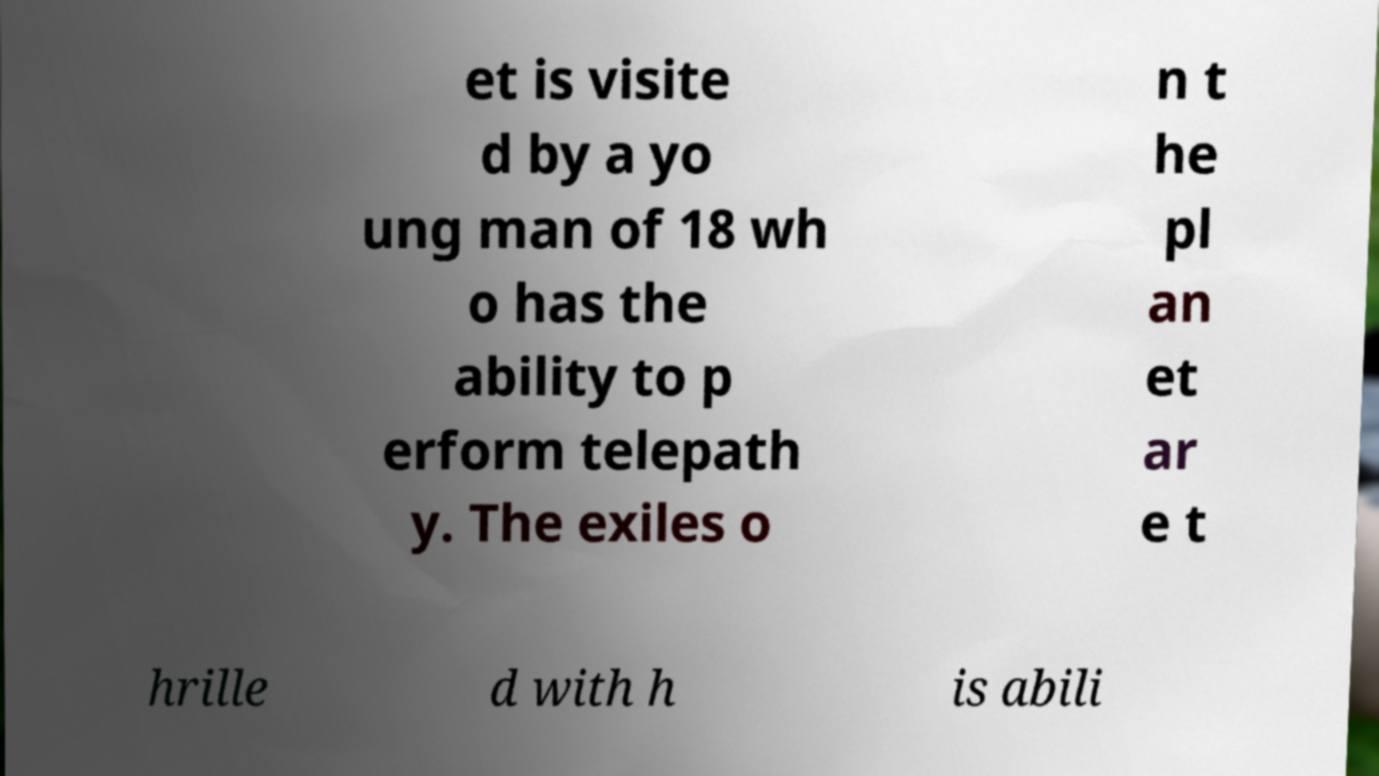What messages or text are displayed in this image? I need them in a readable, typed format. et is visite d by a yo ung man of 18 wh o has the ability to p erform telepath y. The exiles o n t he pl an et ar e t hrille d with h is abili 